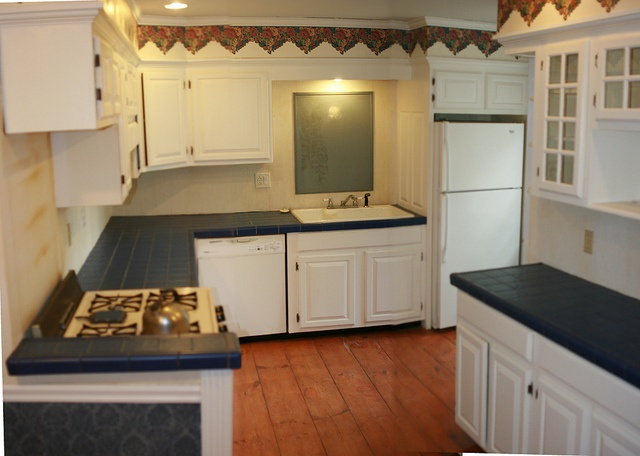Describe the objects in this image and their specific colors. I can see refrigerator in white, darkgray, lightgray, and gray tones, oven in white, black, maroon, and tan tones, and sink in white and tan tones in this image. 